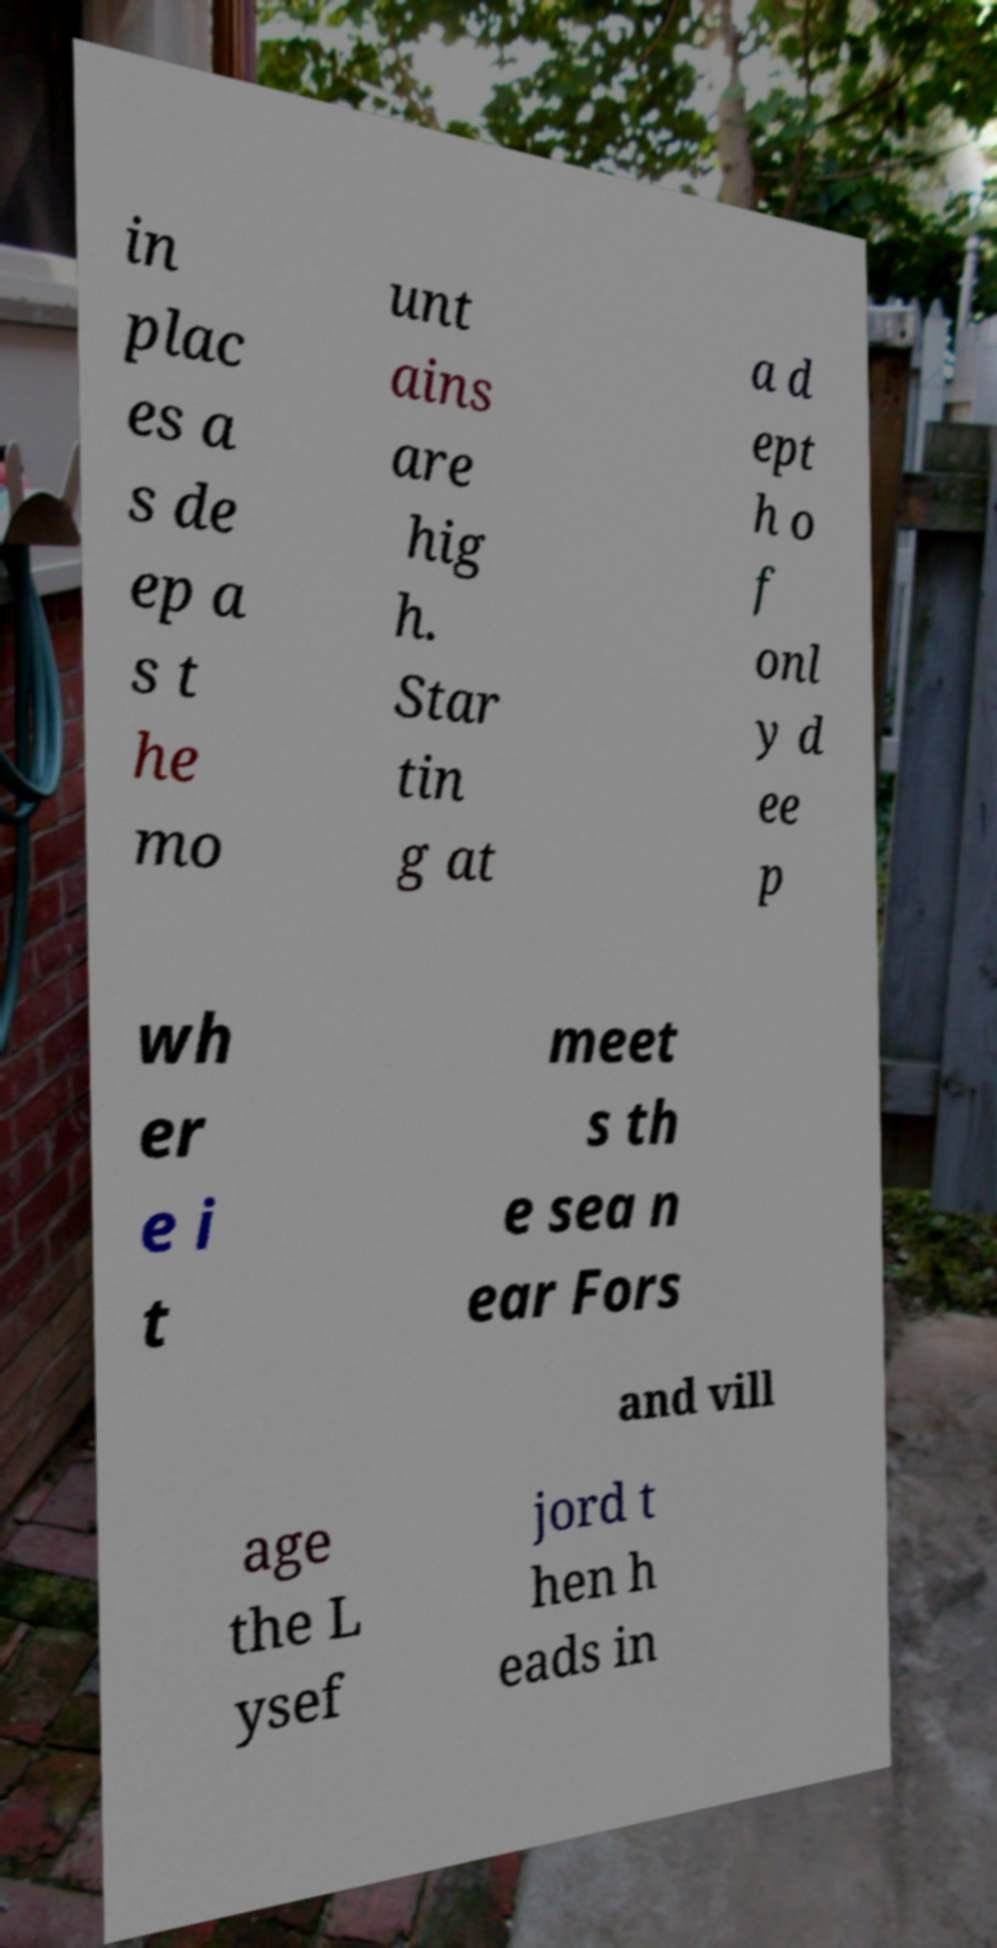There's text embedded in this image that I need extracted. Can you transcribe it verbatim? in plac es a s de ep a s t he mo unt ains are hig h. Star tin g at a d ept h o f onl y d ee p wh er e i t meet s th e sea n ear Fors and vill age the L ysef jord t hen h eads in 